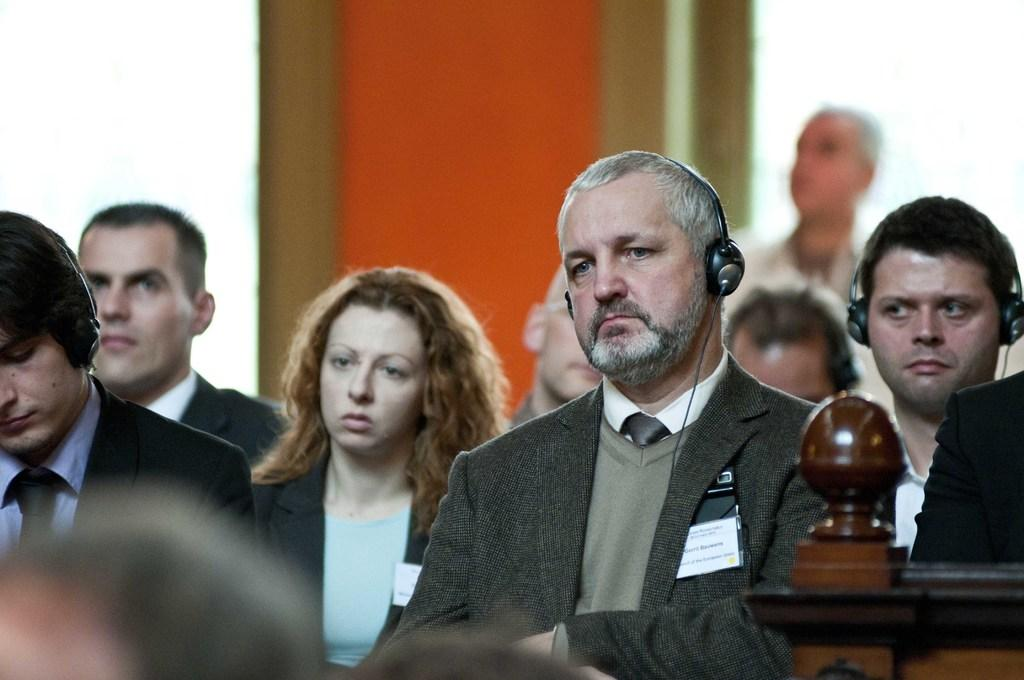What are the people in the image doing? The people in the image are sitting. What can be seen in the background of the image? There is a wall in the background of the image. Are there any other people visible in the image? Yes, there is a man standing in the background of the image. What type of scissors can be seen cutting the system in the image? There are no scissors or systems present in the image. How many cents are visible on the wall in the image? There are no cents visible on the wall in the image. 